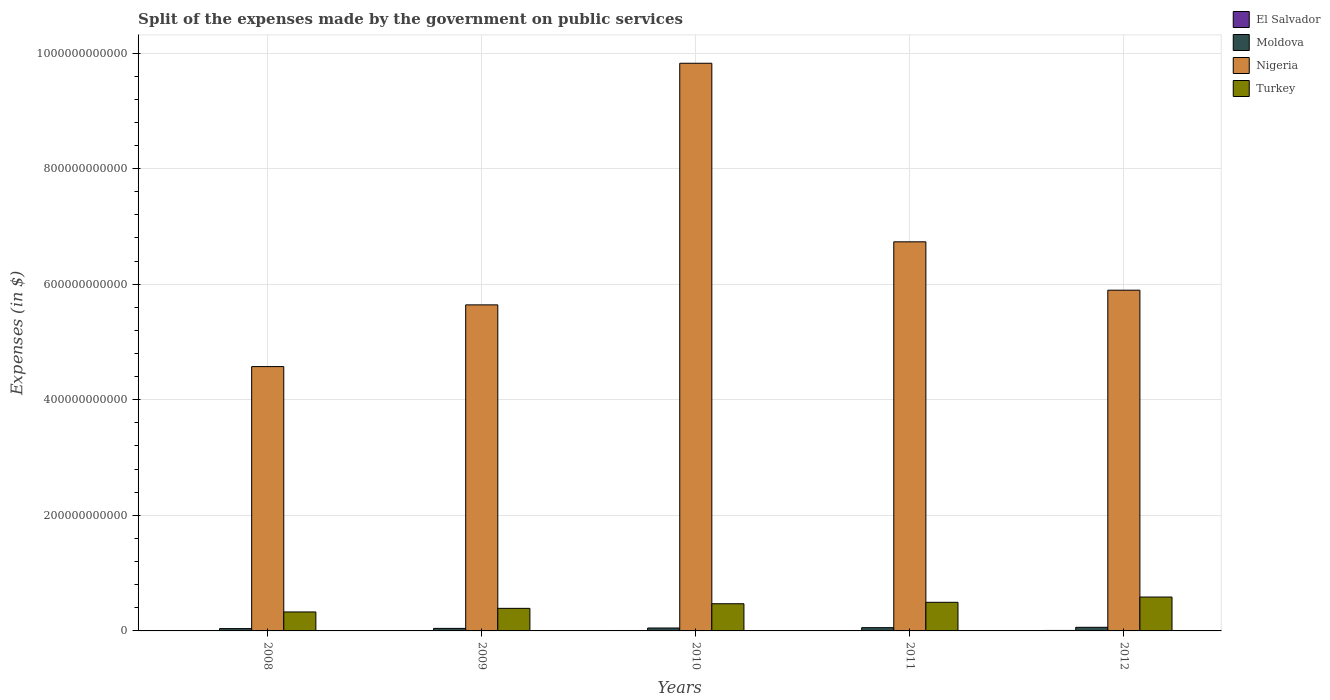Are the number of bars per tick equal to the number of legend labels?
Ensure brevity in your answer.  Yes. Are the number of bars on each tick of the X-axis equal?
Offer a very short reply. Yes. How many bars are there on the 3rd tick from the right?
Provide a succinct answer. 4. What is the expenses made by the government on public services in Turkey in 2012?
Provide a short and direct response. 5.86e+1. Across all years, what is the maximum expenses made by the government on public services in Nigeria?
Provide a succinct answer. 9.82e+11. Across all years, what is the minimum expenses made by the government on public services in El Salvador?
Provide a succinct answer. 6.58e+08. In which year was the expenses made by the government on public services in El Salvador maximum?
Keep it short and to the point. 2012. In which year was the expenses made by the government on public services in El Salvador minimum?
Keep it short and to the point. 2011. What is the total expenses made by the government on public services in Moldova in the graph?
Offer a terse response. 2.53e+1. What is the difference between the expenses made by the government on public services in Moldova in 2008 and that in 2012?
Give a very brief answer. -2.24e+09. What is the difference between the expenses made by the government on public services in Moldova in 2008 and the expenses made by the government on public services in Nigeria in 2009?
Provide a short and direct response. -5.60e+11. What is the average expenses made by the government on public services in Moldova per year?
Your response must be concise. 5.07e+09. In the year 2012, what is the difference between the expenses made by the government on public services in El Salvador and expenses made by the government on public services in Nigeria?
Offer a terse response. -5.89e+11. What is the ratio of the expenses made by the government on public services in El Salvador in 2009 to that in 2010?
Offer a terse response. 0.9. What is the difference between the highest and the second highest expenses made by the government on public services in Moldova?
Keep it short and to the point. 6.26e+08. What is the difference between the highest and the lowest expenses made by the government on public services in Nigeria?
Your answer should be very brief. 5.25e+11. In how many years, is the expenses made by the government on public services in El Salvador greater than the average expenses made by the government on public services in El Salvador taken over all years?
Keep it short and to the point. 2. Is it the case that in every year, the sum of the expenses made by the government on public services in Nigeria and expenses made by the government on public services in Turkey is greater than the sum of expenses made by the government on public services in El Salvador and expenses made by the government on public services in Moldova?
Ensure brevity in your answer.  No. What does the 2nd bar from the left in 2010 represents?
Offer a very short reply. Moldova. What does the 2nd bar from the right in 2008 represents?
Make the answer very short. Nigeria. Is it the case that in every year, the sum of the expenses made by the government on public services in El Salvador and expenses made by the government on public services in Nigeria is greater than the expenses made by the government on public services in Turkey?
Offer a very short reply. Yes. What is the difference between two consecutive major ticks on the Y-axis?
Ensure brevity in your answer.  2.00e+11. Does the graph contain any zero values?
Give a very brief answer. No. What is the title of the graph?
Make the answer very short. Split of the expenses made by the government on public services. What is the label or title of the X-axis?
Provide a succinct answer. Years. What is the label or title of the Y-axis?
Your answer should be compact. Expenses (in $). What is the Expenses (in $) of El Salvador in 2008?
Keep it short and to the point. 6.76e+08. What is the Expenses (in $) in Moldova in 2008?
Your answer should be very brief. 4.02e+09. What is the Expenses (in $) in Nigeria in 2008?
Provide a short and direct response. 4.57e+11. What is the Expenses (in $) in Turkey in 2008?
Your answer should be very brief. 3.28e+1. What is the Expenses (in $) in El Salvador in 2009?
Your answer should be compact. 6.78e+08. What is the Expenses (in $) in Moldova in 2009?
Make the answer very short. 4.41e+09. What is the Expenses (in $) of Nigeria in 2009?
Give a very brief answer. 5.64e+11. What is the Expenses (in $) of Turkey in 2009?
Keep it short and to the point. 3.91e+1. What is the Expenses (in $) in El Salvador in 2010?
Your answer should be compact. 7.50e+08. What is the Expenses (in $) of Moldova in 2010?
Offer a terse response. 5.03e+09. What is the Expenses (in $) in Nigeria in 2010?
Provide a short and direct response. 9.82e+11. What is the Expenses (in $) of Turkey in 2010?
Keep it short and to the point. 4.70e+1. What is the Expenses (in $) in El Salvador in 2011?
Ensure brevity in your answer.  6.58e+08. What is the Expenses (in $) of Moldova in 2011?
Offer a terse response. 5.63e+09. What is the Expenses (in $) of Nigeria in 2011?
Keep it short and to the point. 6.73e+11. What is the Expenses (in $) in Turkey in 2011?
Your answer should be very brief. 4.95e+1. What is the Expenses (in $) in El Salvador in 2012?
Your response must be concise. 8.12e+08. What is the Expenses (in $) of Moldova in 2012?
Keep it short and to the point. 6.25e+09. What is the Expenses (in $) of Nigeria in 2012?
Keep it short and to the point. 5.90e+11. What is the Expenses (in $) in Turkey in 2012?
Your answer should be compact. 5.86e+1. Across all years, what is the maximum Expenses (in $) of El Salvador?
Your answer should be very brief. 8.12e+08. Across all years, what is the maximum Expenses (in $) in Moldova?
Your answer should be compact. 6.25e+09. Across all years, what is the maximum Expenses (in $) of Nigeria?
Give a very brief answer. 9.82e+11. Across all years, what is the maximum Expenses (in $) in Turkey?
Your response must be concise. 5.86e+1. Across all years, what is the minimum Expenses (in $) in El Salvador?
Your response must be concise. 6.58e+08. Across all years, what is the minimum Expenses (in $) in Moldova?
Your answer should be compact. 4.02e+09. Across all years, what is the minimum Expenses (in $) of Nigeria?
Keep it short and to the point. 4.57e+11. Across all years, what is the minimum Expenses (in $) of Turkey?
Provide a short and direct response. 3.28e+1. What is the total Expenses (in $) in El Salvador in the graph?
Make the answer very short. 3.57e+09. What is the total Expenses (in $) of Moldova in the graph?
Offer a terse response. 2.53e+1. What is the total Expenses (in $) of Nigeria in the graph?
Your answer should be very brief. 3.27e+12. What is the total Expenses (in $) in Turkey in the graph?
Offer a very short reply. 2.27e+11. What is the difference between the Expenses (in $) of El Salvador in 2008 and that in 2009?
Offer a very short reply. -2.60e+06. What is the difference between the Expenses (in $) of Moldova in 2008 and that in 2009?
Keep it short and to the point. -3.88e+08. What is the difference between the Expenses (in $) of Nigeria in 2008 and that in 2009?
Provide a succinct answer. -1.07e+11. What is the difference between the Expenses (in $) in Turkey in 2008 and that in 2009?
Your answer should be compact. -6.22e+09. What is the difference between the Expenses (in $) of El Salvador in 2008 and that in 2010?
Ensure brevity in your answer.  -7.44e+07. What is the difference between the Expenses (in $) of Moldova in 2008 and that in 2010?
Your answer should be very brief. -1.02e+09. What is the difference between the Expenses (in $) in Nigeria in 2008 and that in 2010?
Provide a short and direct response. -5.25e+11. What is the difference between the Expenses (in $) of Turkey in 2008 and that in 2010?
Your response must be concise. -1.42e+1. What is the difference between the Expenses (in $) in El Salvador in 2008 and that in 2011?
Give a very brief answer. 1.77e+07. What is the difference between the Expenses (in $) of Moldova in 2008 and that in 2011?
Make the answer very short. -1.61e+09. What is the difference between the Expenses (in $) of Nigeria in 2008 and that in 2011?
Provide a short and direct response. -2.16e+11. What is the difference between the Expenses (in $) in Turkey in 2008 and that in 2011?
Offer a terse response. -1.67e+1. What is the difference between the Expenses (in $) in El Salvador in 2008 and that in 2012?
Keep it short and to the point. -1.37e+08. What is the difference between the Expenses (in $) of Moldova in 2008 and that in 2012?
Your answer should be compact. -2.24e+09. What is the difference between the Expenses (in $) of Nigeria in 2008 and that in 2012?
Provide a succinct answer. -1.32e+11. What is the difference between the Expenses (in $) in Turkey in 2008 and that in 2012?
Your response must be concise. -2.58e+1. What is the difference between the Expenses (in $) of El Salvador in 2009 and that in 2010?
Provide a succinct answer. -7.18e+07. What is the difference between the Expenses (in $) in Moldova in 2009 and that in 2010?
Your response must be concise. -6.28e+08. What is the difference between the Expenses (in $) in Nigeria in 2009 and that in 2010?
Make the answer very short. -4.18e+11. What is the difference between the Expenses (in $) in Turkey in 2009 and that in 2010?
Keep it short and to the point. -7.96e+09. What is the difference between the Expenses (in $) of El Salvador in 2009 and that in 2011?
Give a very brief answer. 2.03e+07. What is the difference between the Expenses (in $) of Moldova in 2009 and that in 2011?
Provide a short and direct response. -1.22e+09. What is the difference between the Expenses (in $) in Nigeria in 2009 and that in 2011?
Provide a succinct answer. -1.09e+11. What is the difference between the Expenses (in $) in Turkey in 2009 and that in 2011?
Keep it short and to the point. -1.05e+1. What is the difference between the Expenses (in $) in El Salvador in 2009 and that in 2012?
Ensure brevity in your answer.  -1.34e+08. What is the difference between the Expenses (in $) of Moldova in 2009 and that in 2012?
Your answer should be compact. -1.85e+09. What is the difference between the Expenses (in $) in Nigeria in 2009 and that in 2012?
Ensure brevity in your answer.  -2.54e+1. What is the difference between the Expenses (in $) of Turkey in 2009 and that in 2012?
Provide a short and direct response. -1.96e+1. What is the difference between the Expenses (in $) of El Salvador in 2010 and that in 2011?
Provide a short and direct response. 9.21e+07. What is the difference between the Expenses (in $) in Moldova in 2010 and that in 2011?
Your response must be concise. -5.93e+08. What is the difference between the Expenses (in $) of Nigeria in 2010 and that in 2011?
Your answer should be very brief. 3.09e+11. What is the difference between the Expenses (in $) of Turkey in 2010 and that in 2011?
Your answer should be compact. -2.49e+09. What is the difference between the Expenses (in $) of El Salvador in 2010 and that in 2012?
Offer a very short reply. -6.24e+07. What is the difference between the Expenses (in $) in Moldova in 2010 and that in 2012?
Give a very brief answer. -1.22e+09. What is the difference between the Expenses (in $) of Nigeria in 2010 and that in 2012?
Your answer should be compact. 3.93e+11. What is the difference between the Expenses (in $) in Turkey in 2010 and that in 2012?
Your answer should be compact. -1.16e+1. What is the difference between the Expenses (in $) of El Salvador in 2011 and that in 2012?
Keep it short and to the point. -1.55e+08. What is the difference between the Expenses (in $) of Moldova in 2011 and that in 2012?
Keep it short and to the point. -6.26e+08. What is the difference between the Expenses (in $) of Nigeria in 2011 and that in 2012?
Ensure brevity in your answer.  8.37e+1. What is the difference between the Expenses (in $) of Turkey in 2011 and that in 2012?
Provide a succinct answer. -9.12e+09. What is the difference between the Expenses (in $) of El Salvador in 2008 and the Expenses (in $) of Moldova in 2009?
Provide a succinct answer. -3.73e+09. What is the difference between the Expenses (in $) in El Salvador in 2008 and the Expenses (in $) in Nigeria in 2009?
Offer a terse response. -5.64e+11. What is the difference between the Expenses (in $) in El Salvador in 2008 and the Expenses (in $) in Turkey in 2009?
Your response must be concise. -3.84e+1. What is the difference between the Expenses (in $) of Moldova in 2008 and the Expenses (in $) of Nigeria in 2009?
Your response must be concise. -5.60e+11. What is the difference between the Expenses (in $) in Moldova in 2008 and the Expenses (in $) in Turkey in 2009?
Give a very brief answer. -3.50e+1. What is the difference between the Expenses (in $) of Nigeria in 2008 and the Expenses (in $) of Turkey in 2009?
Provide a short and direct response. 4.18e+11. What is the difference between the Expenses (in $) in El Salvador in 2008 and the Expenses (in $) in Moldova in 2010?
Ensure brevity in your answer.  -4.36e+09. What is the difference between the Expenses (in $) in El Salvador in 2008 and the Expenses (in $) in Nigeria in 2010?
Keep it short and to the point. -9.82e+11. What is the difference between the Expenses (in $) in El Salvador in 2008 and the Expenses (in $) in Turkey in 2010?
Your answer should be very brief. -4.63e+1. What is the difference between the Expenses (in $) in Moldova in 2008 and the Expenses (in $) in Nigeria in 2010?
Ensure brevity in your answer.  -9.78e+11. What is the difference between the Expenses (in $) of Moldova in 2008 and the Expenses (in $) of Turkey in 2010?
Offer a very short reply. -4.30e+1. What is the difference between the Expenses (in $) in Nigeria in 2008 and the Expenses (in $) in Turkey in 2010?
Provide a succinct answer. 4.10e+11. What is the difference between the Expenses (in $) in El Salvador in 2008 and the Expenses (in $) in Moldova in 2011?
Give a very brief answer. -4.95e+09. What is the difference between the Expenses (in $) in El Salvador in 2008 and the Expenses (in $) in Nigeria in 2011?
Your response must be concise. -6.73e+11. What is the difference between the Expenses (in $) of El Salvador in 2008 and the Expenses (in $) of Turkey in 2011?
Offer a very short reply. -4.88e+1. What is the difference between the Expenses (in $) of Moldova in 2008 and the Expenses (in $) of Nigeria in 2011?
Provide a succinct answer. -6.69e+11. What is the difference between the Expenses (in $) in Moldova in 2008 and the Expenses (in $) in Turkey in 2011?
Your answer should be very brief. -4.55e+1. What is the difference between the Expenses (in $) in Nigeria in 2008 and the Expenses (in $) in Turkey in 2011?
Give a very brief answer. 4.08e+11. What is the difference between the Expenses (in $) in El Salvador in 2008 and the Expenses (in $) in Moldova in 2012?
Your response must be concise. -5.58e+09. What is the difference between the Expenses (in $) of El Salvador in 2008 and the Expenses (in $) of Nigeria in 2012?
Your answer should be compact. -5.89e+11. What is the difference between the Expenses (in $) of El Salvador in 2008 and the Expenses (in $) of Turkey in 2012?
Provide a succinct answer. -5.80e+1. What is the difference between the Expenses (in $) of Moldova in 2008 and the Expenses (in $) of Nigeria in 2012?
Your answer should be very brief. -5.86e+11. What is the difference between the Expenses (in $) of Moldova in 2008 and the Expenses (in $) of Turkey in 2012?
Offer a terse response. -5.46e+1. What is the difference between the Expenses (in $) of Nigeria in 2008 and the Expenses (in $) of Turkey in 2012?
Provide a succinct answer. 3.99e+11. What is the difference between the Expenses (in $) in El Salvador in 2009 and the Expenses (in $) in Moldova in 2010?
Offer a terse response. -4.36e+09. What is the difference between the Expenses (in $) of El Salvador in 2009 and the Expenses (in $) of Nigeria in 2010?
Your answer should be very brief. -9.82e+11. What is the difference between the Expenses (in $) in El Salvador in 2009 and the Expenses (in $) in Turkey in 2010?
Ensure brevity in your answer.  -4.63e+1. What is the difference between the Expenses (in $) of Moldova in 2009 and the Expenses (in $) of Nigeria in 2010?
Your response must be concise. -9.78e+11. What is the difference between the Expenses (in $) of Moldova in 2009 and the Expenses (in $) of Turkey in 2010?
Give a very brief answer. -4.26e+1. What is the difference between the Expenses (in $) in Nigeria in 2009 and the Expenses (in $) in Turkey in 2010?
Your answer should be compact. 5.17e+11. What is the difference between the Expenses (in $) of El Salvador in 2009 and the Expenses (in $) of Moldova in 2011?
Make the answer very short. -4.95e+09. What is the difference between the Expenses (in $) of El Salvador in 2009 and the Expenses (in $) of Nigeria in 2011?
Make the answer very short. -6.73e+11. What is the difference between the Expenses (in $) of El Salvador in 2009 and the Expenses (in $) of Turkey in 2011?
Make the answer very short. -4.88e+1. What is the difference between the Expenses (in $) in Moldova in 2009 and the Expenses (in $) in Nigeria in 2011?
Your answer should be compact. -6.69e+11. What is the difference between the Expenses (in $) in Moldova in 2009 and the Expenses (in $) in Turkey in 2011?
Ensure brevity in your answer.  -4.51e+1. What is the difference between the Expenses (in $) of Nigeria in 2009 and the Expenses (in $) of Turkey in 2011?
Make the answer very short. 5.15e+11. What is the difference between the Expenses (in $) in El Salvador in 2009 and the Expenses (in $) in Moldova in 2012?
Give a very brief answer. -5.57e+09. What is the difference between the Expenses (in $) of El Salvador in 2009 and the Expenses (in $) of Nigeria in 2012?
Provide a short and direct response. -5.89e+11. What is the difference between the Expenses (in $) of El Salvador in 2009 and the Expenses (in $) of Turkey in 2012?
Make the answer very short. -5.79e+1. What is the difference between the Expenses (in $) of Moldova in 2009 and the Expenses (in $) of Nigeria in 2012?
Make the answer very short. -5.85e+11. What is the difference between the Expenses (in $) in Moldova in 2009 and the Expenses (in $) in Turkey in 2012?
Ensure brevity in your answer.  -5.42e+1. What is the difference between the Expenses (in $) in Nigeria in 2009 and the Expenses (in $) in Turkey in 2012?
Provide a succinct answer. 5.06e+11. What is the difference between the Expenses (in $) in El Salvador in 2010 and the Expenses (in $) in Moldova in 2011?
Provide a short and direct response. -4.88e+09. What is the difference between the Expenses (in $) in El Salvador in 2010 and the Expenses (in $) in Nigeria in 2011?
Offer a very short reply. -6.73e+11. What is the difference between the Expenses (in $) in El Salvador in 2010 and the Expenses (in $) in Turkey in 2011?
Provide a short and direct response. -4.88e+1. What is the difference between the Expenses (in $) in Moldova in 2010 and the Expenses (in $) in Nigeria in 2011?
Your response must be concise. -6.68e+11. What is the difference between the Expenses (in $) in Moldova in 2010 and the Expenses (in $) in Turkey in 2011?
Offer a terse response. -4.45e+1. What is the difference between the Expenses (in $) of Nigeria in 2010 and the Expenses (in $) of Turkey in 2011?
Ensure brevity in your answer.  9.33e+11. What is the difference between the Expenses (in $) of El Salvador in 2010 and the Expenses (in $) of Moldova in 2012?
Keep it short and to the point. -5.50e+09. What is the difference between the Expenses (in $) of El Salvador in 2010 and the Expenses (in $) of Nigeria in 2012?
Keep it short and to the point. -5.89e+11. What is the difference between the Expenses (in $) of El Salvador in 2010 and the Expenses (in $) of Turkey in 2012?
Your response must be concise. -5.79e+1. What is the difference between the Expenses (in $) in Moldova in 2010 and the Expenses (in $) in Nigeria in 2012?
Offer a very short reply. -5.85e+11. What is the difference between the Expenses (in $) of Moldova in 2010 and the Expenses (in $) of Turkey in 2012?
Provide a succinct answer. -5.36e+1. What is the difference between the Expenses (in $) in Nigeria in 2010 and the Expenses (in $) in Turkey in 2012?
Provide a short and direct response. 9.24e+11. What is the difference between the Expenses (in $) of El Salvador in 2011 and the Expenses (in $) of Moldova in 2012?
Your answer should be compact. -5.59e+09. What is the difference between the Expenses (in $) of El Salvador in 2011 and the Expenses (in $) of Nigeria in 2012?
Provide a short and direct response. -5.89e+11. What is the difference between the Expenses (in $) of El Salvador in 2011 and the Expenses (in $) of Turkey in 2012?
Give a very brief answer. -5.80e+1. What is the difference between the Expenses (in $) in Moldova in 2011 and the Expenses (in $) in Nigeria in 2012?
Give a very brief answer. -5.84e+11. What is the difference between the Expenses (in $) in Moldova in 2011 and the Expenses (in $) in Turkey in 2012?
Provide a short and direct response. -5.30e+1. What is the difference between the Expenses (in $) in Nigeria in 2011 and the Expenses (in $) in Turkey in 2012?
Keep it short and to the point. 6.15e+11. What is the average Expenses (in $) in El Salvador per year?
Your response must be concise. 7.15e+08. What is the average Expenses (in $) of Moldova per year?
Provide a succinct answer. 5.07e+09. What is the average Expenses (in $) in Nigeria per year?
Give a very brief answer. 6.53e+11. What is the average Expenses (in $) of Turkey per year?
Your answer should be very brief. 4.54e+1. In the year 2008, what is the difference between the Expenses (in $) in El Salvador and Expenses (in $) in Moldova?
Ensure brevity in your answer.  -3.34e+09. In the year 2008, what is the difference between the Expenses (in $) in El Salvador and Expenses (in $) in Nigeria?
Your response must be concise. -4.57e+11. In the year 2008, what is the difference between the Expenses (in $) in El Salvador and Expenses (in $) in Turkey?
Give a very brief answer. -3.22e+1. In the year 2008, what is the difference between the Expenses (in $) of Moldova and Expenses (in $) of Nigeria?
Ensure brevity in your answer.  -4.53e+11. In the year 2008, what is the difference between the Expenses (in $) of Moldova and Expenses (in $) of Turkey?
Provide a succinct answer. -2.88e+1. In the year 2008, what is the difference between the Expenses (in $) in Nigeria and Expenses (in $) in Turkey?
Ensure brevity in your answer.  4.25e+11. In the year 2009, what is the difference between the Expenses (in $) of El Salvador and Expenses (in $) of Moldova?
Provide a short and direct response. -3.73e+09. In the year 2009, what is the difference between the Expenses (in $) in El Salvador and Expenses (in $) in Nigeria?
Your response must be concise. -5.64e+11. In the year 2009, what is the difference between the Expenses (in $) in El Salvador and Expenses (in $) in Turkey?
Make the answer very short. -3.84e+1. In the year 2009, what is the difference between the Expenses (in $) in Moldova and Expenses (in $) in Nigeria?
Keep it short and to the point. -5.60e+11. In the year 2009, what is the difference between the Expenses (in $) of Moldova and Expenses (in $) of Turkey?
Make the answer very short. -3.47e+1. In the year 2009, what is the difference between the Expenses (in $) in Nigeria and Expenses (in $) in Turkey?
Make the answer very short. 5.25e+11. In the year 2010, what is the difference between the Expenses (in $) in El Salvador and Expenses (in $) in Moldova?
Provide a short and direct response. -4.28e+09. In the year 2010, what is the difference between the Expenses (in $) in El Salvador and Expenses (in $) in Nigeria?
Provide a succinct answer. -9.82e+11. In the year 2010, what is the difference between the Expenses (in $) of El Salvador and Expenses (in $) of Turkey?
Make the answer very short. -4.63e+1. In the year 2010, what is the difference between the Expenses (in $) in Moldova and Expenses (in $) in Nigeria?
Provide a short and direct response. -9.77e+11. In the year 2010, what is the difference between the Expenses (in $) in Moldova and Expenses (in $) in Turkey?
Keep it short and to the point. -4.20e+1. In the year 2010, what is the difference between the Expenses (in $) in Nigeria and Expenses (in $) in Turkey?
Provide a succinct answer. 9.35e+11. In the year 2011, what is the difference between the Expenses (in $) of El Salvador and Expenses (in $) of Moldova?
Your answer should be very brief. -4.97e+09. In the year 2011, what is the difference between the Expenses (in $) of El Salvador and Expenses (in $) of Nigeria?
Give a very brief answer. -6.73e+11. In the year 2011, what is the difference between the Expenses (in $) of El Salvador and Expenses (in $) of Turkey?
Ensure brevity in your answer.  -4.89e+1. In the year 2011, what is the difference between the Expenses (in $) in Moldova and Expenses (in $) in Nigeria?
Offer a very short reply. -6.68e+11. In the year 2011, what is the difference between the Expenses (in $) in Moldova and Expenses (in $) in Turkey?
Provide a short and direct response. -4.39e+1. In the year 2011, what is the difference between the Expenses (in $) in Nigeria and Expenses (in $) in Turkey?
Offer a terse response. 6.24e+11. In the year 2012, what is the difference between the Expenses (in $) of El Salvador and Expenses (in $) of Moldova?
Your answer should be very brief. -5.44e+09. In the year 2012, what is the difference between the Expenses (in $) of El Salvador and Expenses (in $) of Nigeria?
Your answer should be very brief. -5.89e+11. In the year 2012, what is the difference between the Expenses (in $) in El Salvador and Expenses (in $) in Turkey?
Offer a terse response. -5.78e+1. In the year 2012, what is the difference between the Expenses (in $) in Moldova and Expenses (in $) in Nigeria?
Keep it short and to the point. -5.83e+11. In the year 2012, what is the difference between the Expenses (in $) in Moldova and Expenses (in $) in Turkey?
Your answer should be compact. -5.24e+1. In the year 2012, what is the difference between the Expenses (in $) in Nigeria and Expenses (in $) in Turkey?
Provide a succinct answer. 5.31e+11. What is the ratio of the Expenses (in $) of Moldova in 2008 to that in 2009?
Give a very brief answer. 0.91. What is the ratio of the Expenses (in $) of Nigeria in 2008 to that in 2009?
Provide a succinct answer. 0.81. What is the ratio of the Expenses (in $) in Turkey in 2008 to that in 2009?
Your response must be concise. 0.84. What is the ratio of the Expenses (in $) of El Salvador in 2008 to that in 2010?
Ensure brevity in your answer.  0.9. What is the ratio of the Expenses (in $) of Moldova in 2008 to that in 2010?
Your answer should be compact. 0.8. What is the ratio of the Expenses (in $) in Nigeria in 2008 to that in 2010?
Your answer should be very brief. 0.47. What is the ratio of the Expenses (in $) of Turkey in 2008 to that in 2010?
Offer a very short reply. 0.7. What is the ratio of the Expenses (in $) of El Salvador in 2008 to that in 2011?
Make the answer very short. 1.03. What is the ratio of the Expenses (in $) in Moldova in 2008 to that in 2011?
Give a very brief answer. 0.71. What is the ratio of the Expenses (in $) of Nigeria in 2008 to that in 2011?
Provide a succinct answer. 0.68. What is the ratio of the Expenses (in $) in Turkey in 2008 to that in 2011?
Make the answer very short. 0.66. What is the ratio of the Expenses (in $) of El Salvador in 2008 to that in 2012?
Provide a succinct answer. 0.83. What is the ratio of the Expenses (in $) of Moldova in 2008 to that in 2012?
Give a very brief answer. 0.64. What is the ratio of the Expenses (in $) in Nigeria in 2008 to that in 2012?
Provide a succinct answer. 0.78. What is the ratio of the Expenses (in $) in Turkey in 2008 to that in 2012?
Give a very brief answer. 0.56. What is the ratio of the Expenses (in $) in El Salvador in 2009 to that in 2010?
Your answer should be very brief. 0.9. What is the ratio of the Expenses (in $) of Moldova in 2009 to that in 2010?
Give a very brief answer. 0.88. What is the ratio of the Expenses (in $) of Nigeria in 2009 to that in 2010?
Offer a very short reply. 0.57. What is the ratio of the Expenses (in $) of Turkey in 2009 to that in 2010?
Give a very brief answer. 0.83. What is the ratio of the Expenses (in $) in El Salvador in 2009 to that in 2011?
Ensure brevity in your answer.  1.03. What is the ratio of the Expenses (in $) of Moldova in 2009 to that in 2011?
Your response must be concise. 0.78. What is the ratio of the Expenses (in $) of Nigeria in 2009 to that in 2011?
Keep it short and to the point. 0.84. What is the ratio of the Expenses (in $) of Turkey in 2009 to that in 2011?
Offer a very short reply. 0.79. What is the ratio of the Expenses (in $) of El Salvador in 2009 to that in 2012?
Your response must be concise. 0.83. What is the ratio of the Expenses (in $) of Moldova in 2009 to that in 2012?
Offer a very short reply. 0.7. What is the ratio of the Expenses (in $) in Nigeria in 2009 to that in 2012?
Offer a terse response. 0.96. What is the ratio of the Expenses (in $) of Turkey in 2009 to that in 2012?
Your response must be concise. 0.67. What is the ratio of the Expenses (in $) in El Salvador in 2010 to that in 2011?
Offer a terse response. 1.14. What is the ratio of the Expenses (in $) of Moldova in 2010 to that in 2011?
Provide a succinct answer. 0.89. What is the ratio of the Expenses (in $) of Nigeria in 2010 to that in 2011?
Your response must be concise. 1.46. What is the ratio of the Expenses (in $) in Turkey in 2010 to that in 2011?
Make the answer very short. 0.95. What is the ratio of the Expenses (in $) of El Salvador in 2010 to that in 2012?
Make the answer very short. 0.92. What is the ratio of the Expenses (in $) of Moldova in 2010 to that in 2012?
Ensure brevity in your answer.  0.81. What is the ratio of the Expenses (in $) of Nigeria in 2010 to that in 2012?
Your answer should be very brief. 1.67. What is the ratio of the Expenses (in $) of Turkey in 2010 to that in 2012?
Offer a terse response. 0.8. What is the ratio of the Expenses (in $) of El Salvador in 2011 to that in 2012?
Provide a short and direct response. 0.81. What is the ratio of the Expenses (in $) in Moldova in 2011 to that in 2012?
Make the answer very short. 0.9. What is the ratio of the Expenses (in $) in Nigeria in 2011 to that in 2012?
Your response must be concise. 1.14. What is the ratio of the Expenses (in $) in Turkey in 2011 to that in 2012?
Your answer should be compact. 0.84. What is the difference between the highest and the second highest Expenses (in $) of El Salvador?
Give a very brief answer. 6.24e+07. What is the difference between the highest and the second highest Expenses (in $) in Moldova?
Make the answer very short. 6.26e+08. What is the difference between the highest and the second highest Expenses (in $) in Nigeria?
Keep it short and to the point. 3.09e+11. What is the difference between the highest and the second highest Expenses (in $) of Turkey?
Ensure brevity in your answer.  9.12e+09. What is the difference between the highest and the lowest Expenses (in $) of El Salvador?
Give a very brief answer. 1.55e+08. What is the difference between the highest and the lowest Expenses (in $) of Moldova?
Your answer should be compact. 2.24e+09. What is the difference between the highest and the lowest Expenses (in $) of Nigeria?
Your answer should be compact. 5.25e+11. What is the difference between the highest and the lowest Expenses (in $) in Turkey?
Keep it short and to the point. 2.58e+1. 